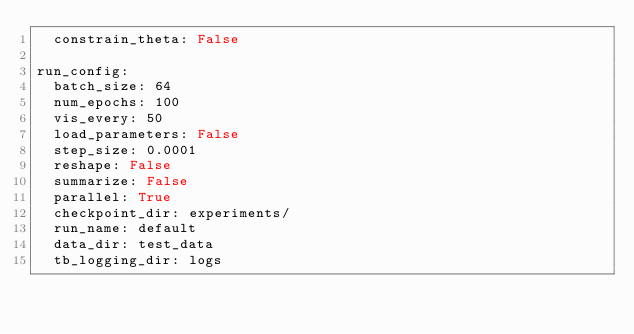Convert code to text. <code><loc_0><loc_0><loc_500><loc_500><_YAML_>  constrain_theta: False

run_config:
  batch_size: 64
  num_epochs: 100
  vis_every: 50
  load_parameters: False
  step_size: 0.0001
  reshape: False
  summarize: False
  parallel: True
  checkpoint_dir: experiments/
  run_name: default
  data_dir: test_data
  tb_logging_dir: logs
</code> 